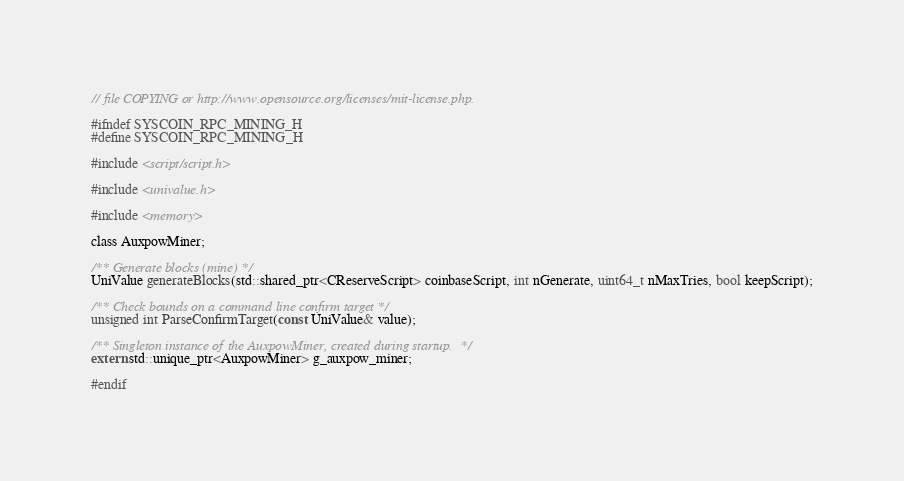Convert code to text. <code><loc_0><loc_0><loc_500><loc_500><_C_>// file COPYING or http://www.opensource.org/licenses/mit-license.php.

#ifndef SYSCOIN_RPC_MINING_H
#define SYSCOIN_RPC_MINING_H

#include <script/script.h>

#include <univalue.h>

#include <memory>

class AuxpowMiner;

/** Generate blocks (mine) */
UniValue generateBlocks(std::shared_ptr<CReserveScript> coinbaseScript, int nGenerate, uint64_t nMaxTries, bool keepScript);

/** Check bounds on a command line confirm target */
unsigned int ParseConfirmTarget(const UniValue& value);

/** Singleton instance of the AuxpowMiner, created during startup.  */
extern std::unique_ptr<AuxpowMiner> g_auxpow_miner;

#endif
</code> 